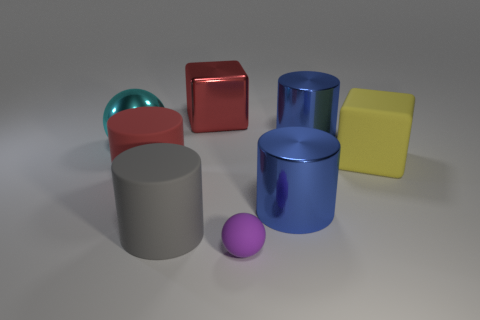Are there any other things that are the same size as the purple rubber sphere?
Provide a short and direct response. No. There is a sphere behind the big matte object that is right of the purple object; what is its size?
Ensure brevity in your answer.  Large. Is the big cyan ball made of the same material as the red cube behind the big red cylinder?
Offer a terse response. Yes. How many blue objects are the same material as the big red block?
Your answer should be very brief. 2. The big red object on the left side of the red metal block has what shape?
Ensure brevity in your answer.  Cylinder. Is the big red thing left of the big gray matte object made of the same material as the sphere to the left of the red cube?
Give a very brief answer. No. Is there a red object of the same shape as the purple rubber thing?
Your response must be concise. No. How many objects are blue metallic objects that are behind the big red cylinder or purple rubber spheres?
Make the answer very short. 2. Are there more big metallic cylinders behind the big red matte object than shiny objects that are behind the large metallic cube?
Offer a terse response. Yes. How many matte objects are either cylinders or red cylinders?
Make the answer very short. 2. 